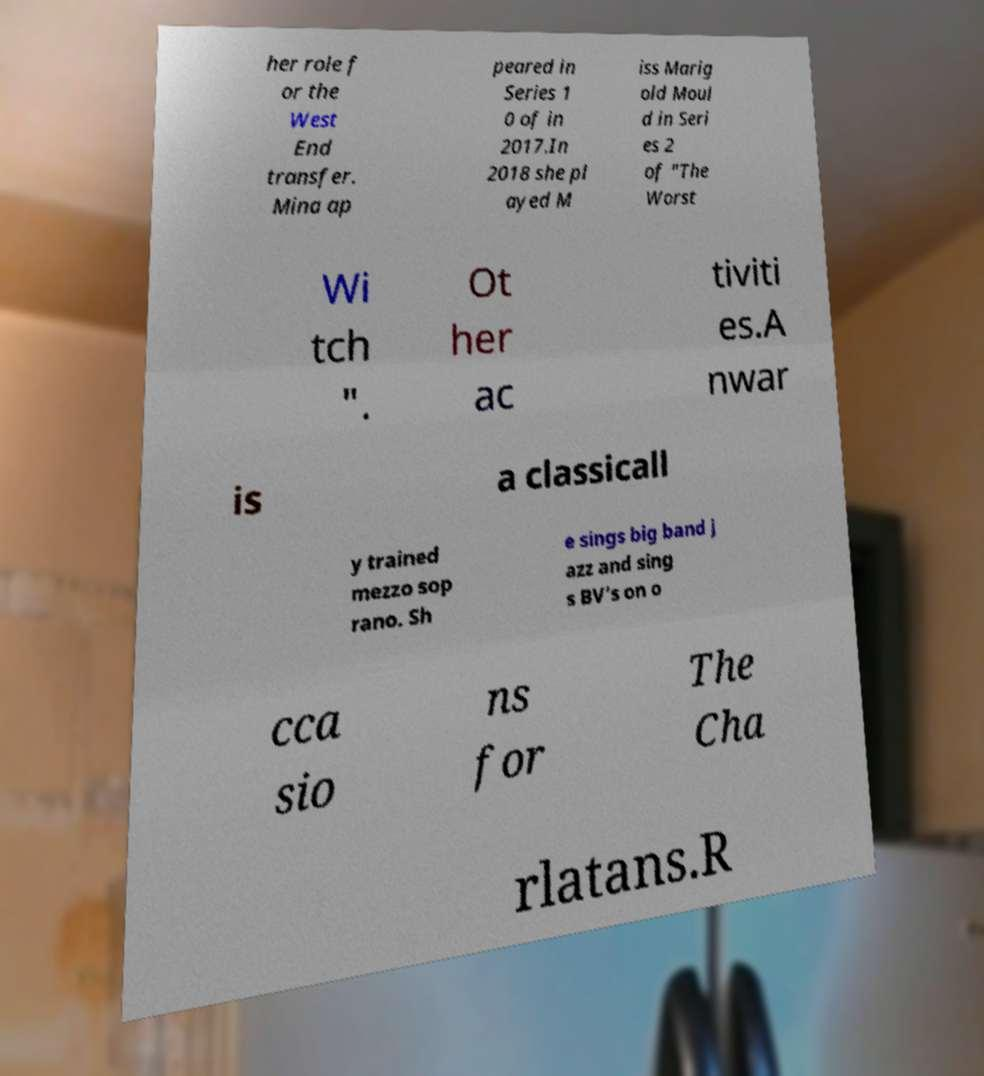Could you extract and type out the text from this image? her role f or the West End transfer. Mina ap peared in Series 1 0 of in 2017.In 2018 she pl ayed M iss Marig old Moul d in Seri es 2 of "The Worst Wi tch ". Ot her ac tiviti es.A nwar is a classicall y trained mezzo sop rano. Sh e sings big band j azz and sing s BV’s on o cca sio ns for The Cha rlatans.R 